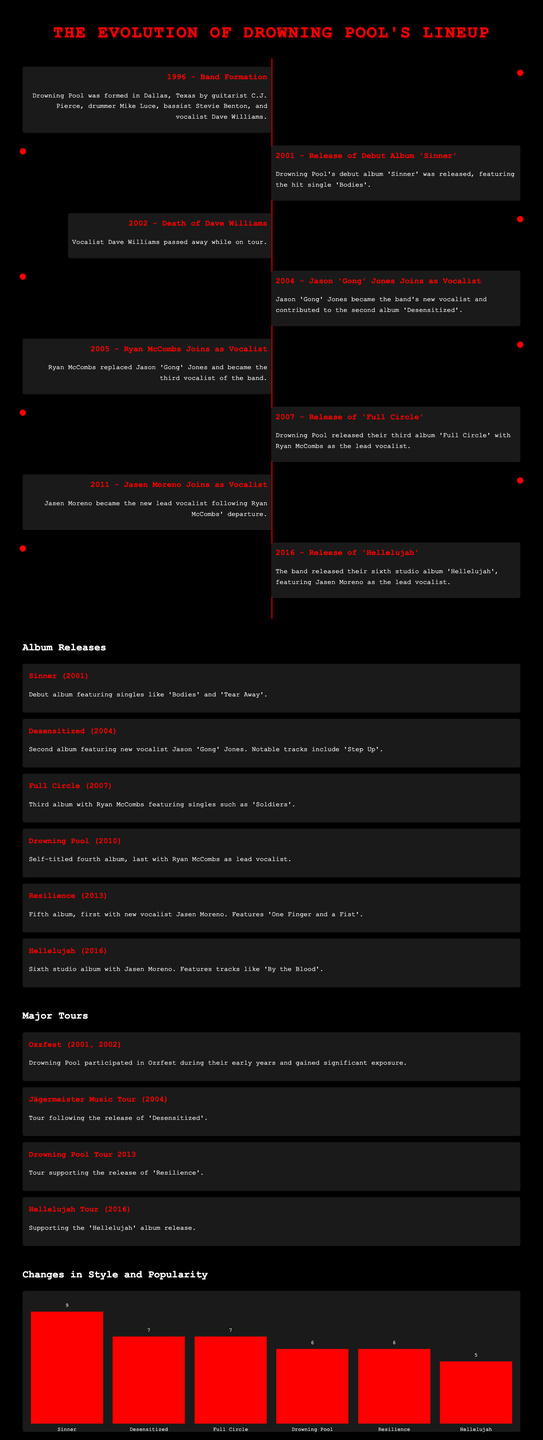What year did Drowning Pool form? The document states that Drowning Pool was formed in 1996.
Answer: 1996 Who was the first vocalist of Drowning Pool? The timeline mentions Dave Williams as the first vocalist of Drowning Pool.
Answer: Dave Williams Which album features the hit single 'Bodies'? The document notes that the debut album 'Sinner' features the hit single 'Bodies'.
Answer: Sinner What significant event happened in 2002? The timeline indicates that vocalist Dave Williams passed away in 2002.
Answer: Death of Dave Williams How many albums were released by Drowning Pool as of 2016? The Album Releases section lists six albums released by Drowning Pool up to 2016.
Answer: Six Which album was released after 'Desensitized'? The document states that 'Full Circle' was released after 'Desensitized'.
Answer: Full Circle What was the major tour in 2004? The document details that the major tour in 2004 was the Jägermeister Music Tour.
Answer: Jägermeister Music Tour What percentage represents the popularity of the album 'Resilience'? The style chart indicates that 'Resilience' has a popularity rating of 6.
Answer: 6 Who replaced Ryan McCombs as vocalist? The timeline specifies that Jasen Moreno became the new lead vocalist after Ryan McCombs.
Answer: Jasen Moreno 